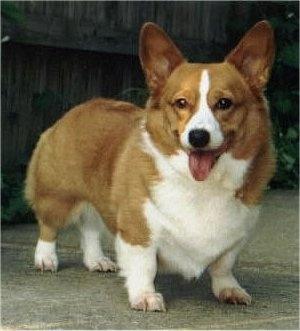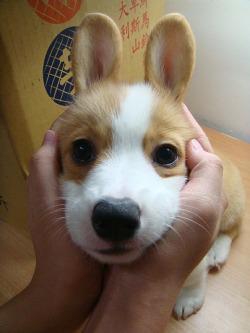The first image is the image on the left, the second image is the image on the right. Given the left and right images, does the statement "At least one image contains only one dog, which is standing on all fours and has its mouth closed." hold true? Answer yes or no. No. The first image is the image on the left, the second image is the image on the right. Assess this claim about the two images: "One of the dogs is near grass, but not actually IN grass.". Correct or not? Answer yes or no. No. 